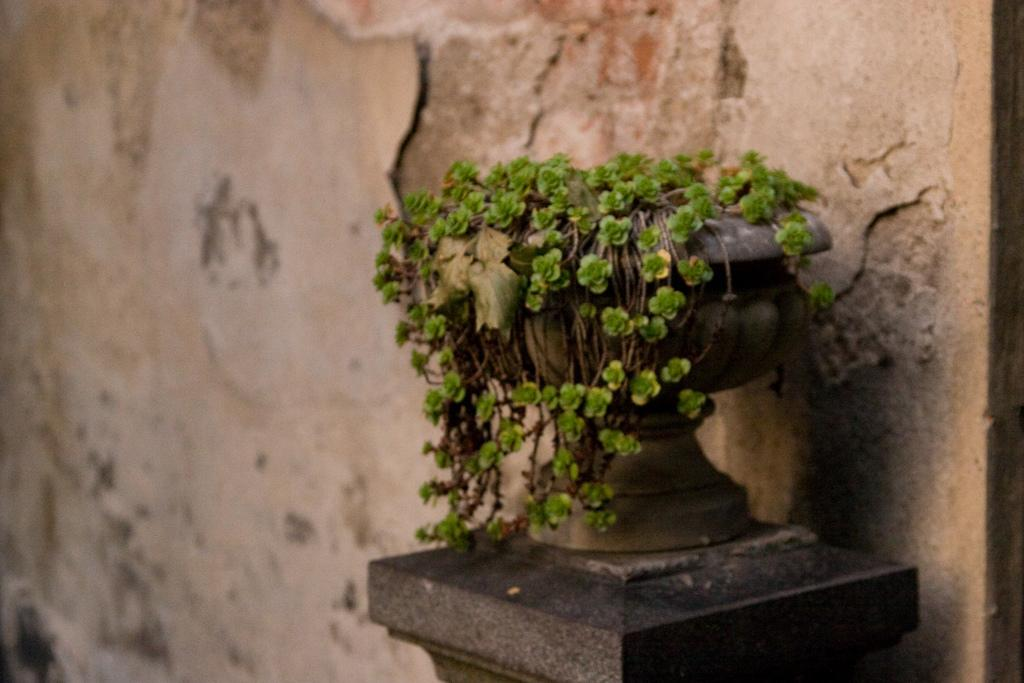What object is the main focus of the image? There is a pot in the image. What is inside the pot? The pot contains plants. What can be seen in the background of the image? There is a wall in the background of the image. What type of rule does the horse follow in the image? There is no horse present in the image, so there is no rule for the horse to follow. 